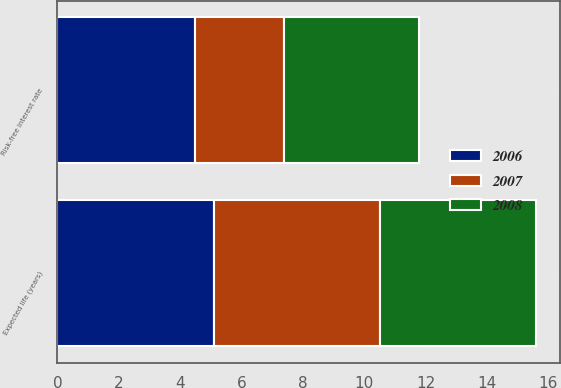Convert chart. <chart><loc_0><loc_0><loc_500><loc_500><stacked_bar_chart><ecel><fcel>Risk-free interest rate<fcel>Expected life (years)<nl><fcel>2007<fcel>2.9<fcel>5.4<nl><fcel>2008<fcel>4.4<fcel>5.1<nl><fcel>2006<fcel>4.5<fcel>5.1<nl></chart> 